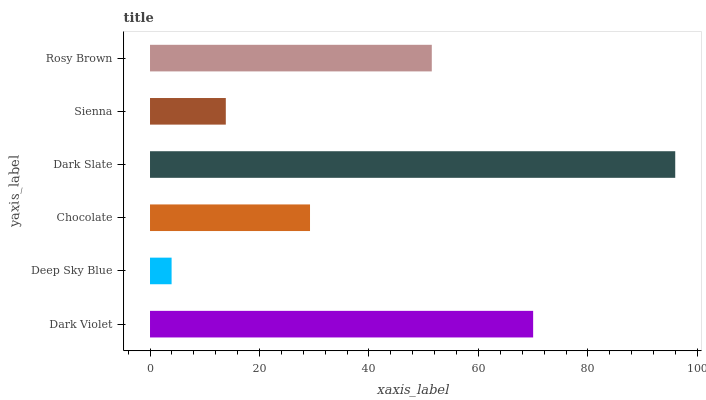Is Deep Sky Blue the minimum?
Answer yes or no. Yes. Is Dark Slate the maximum?
Answer yes or no. Yes. Is Chocolate the minimum?
Answer yes or no. No. Is Chocolate the maximum?
Answer yes or no. No. Is Chocolate greater than Deep Sky Blue?
Answer yes or no. Yes. Is Deep Sky Blue less than Chocolate?
Answer yes or no. Yes. Is Deep Sky Blue greater than Chocolate?
Answer yes or no. No. Is Chocolate less than Deep Sky Blue?
Answer yes or no. No. Is Rosy Brown the high median?
Answer yes or no. Yes. Is Chocolate the low median?
Answer yes or no. Yes. Is Deep Sky Blue the high median?
Answer yes or no. No. Is Dark Slate the low median?
Answer yes or no. No. 